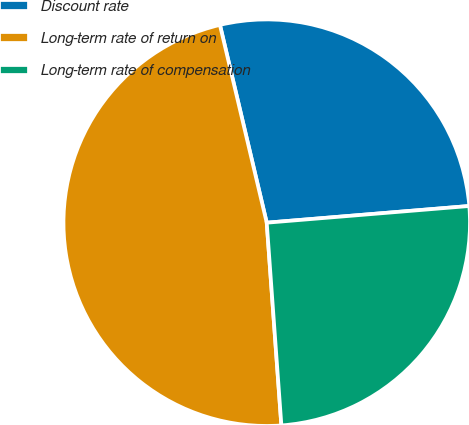Convert chart to OTSL. <chart><loc_0><loc_0><loc_500><loc_500><pie_chart><fcel>Discount rate<fcel>Long-term rate of return on<fcel>Long-term rate of compensation<nl><fcel>27.39%<fcel>47.45%<fcel>25.16%<nl></chart> 